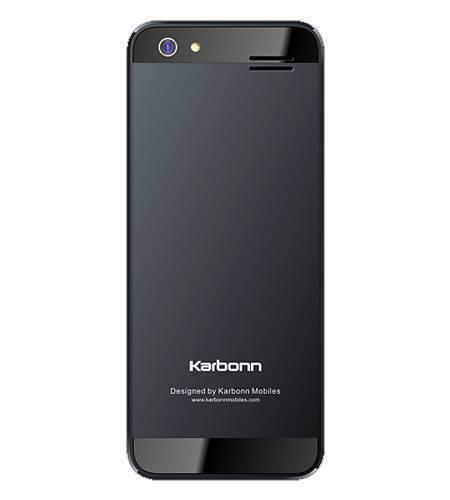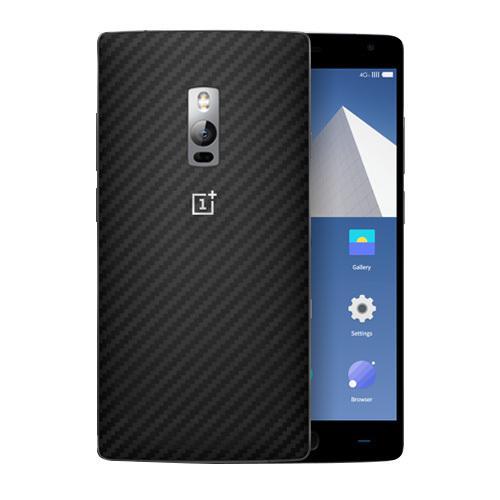The first image is the image on the left, the second image is the image on the right. Considering the images on both sides, is "The phone screen is completely visible in each image." valid? Answer yes or no. No. The first image is the image on the left, the second image is the image on the right. Assess this claim about the two images: "Each image shows a device viewed head-on, and at least one of the images shows an overlapping device.". Correct or not? Answer yes or no. Yes. 